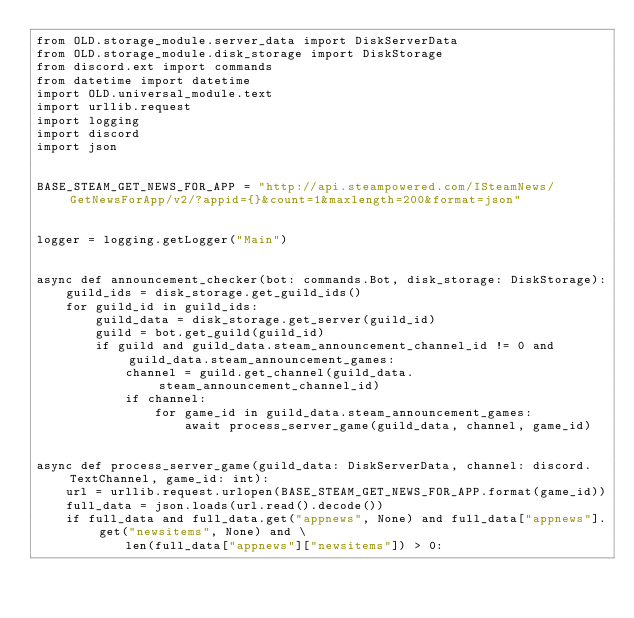<code> <loc_0><loc_0><loc_500><loc_500><_Python_>from OLD.storage_module.server_data import DiskServerData
from OLD.storage_module.disk_storage import DiskStorage
from discord.ext import commands
from datetime import datetime
import OLD.universal_module.text
import urllib.request
import logging
import discord
import json


BASE_STEAM_GET_NEWS_FOR_APP = "http://api.steampowered.com/ISteamNews/GetNewsForApp/v2/?appid={}&count=1&maxlength=200&format=json"


logger = logging.getLogger("Main")


async def announcement_checker(bot: commands.Bot, disk_storage: DiskStorage):
    guild_ids = disk_storage.get_guild_ids()
    for guild_id in guild_ids:
        guild_data = disk_storage.get_server(guild_id)
        guild = bot.get_guild(guild_id)
        if guild and guild_data.steam_announcement_channel_id != 0 and guild_data.steam_announcement_games:
            channel = guild.get_channel(guild_data.steam_announcement_channel_id)
            if channel:
                for game_id in guild_data.steam_announcement_games:
                    await process_server_game(guild_data, channel, game_id)


async def process_server_game(guild_data: DiskServerData, channel: discord.TextChannel, game_id: int):
    url = urllib.request.urlopen(BASE_STEAM_GET_NEWS_FOR_APP.format(game_id))
    full_data = json.loads(url.read().decode())
    if full_data and full_data.get("appnews", None) and full_data["appnews"].get("newsitems", None) and \
            len(full_data["appnews"]["newsitems"]) > 0:</code> 